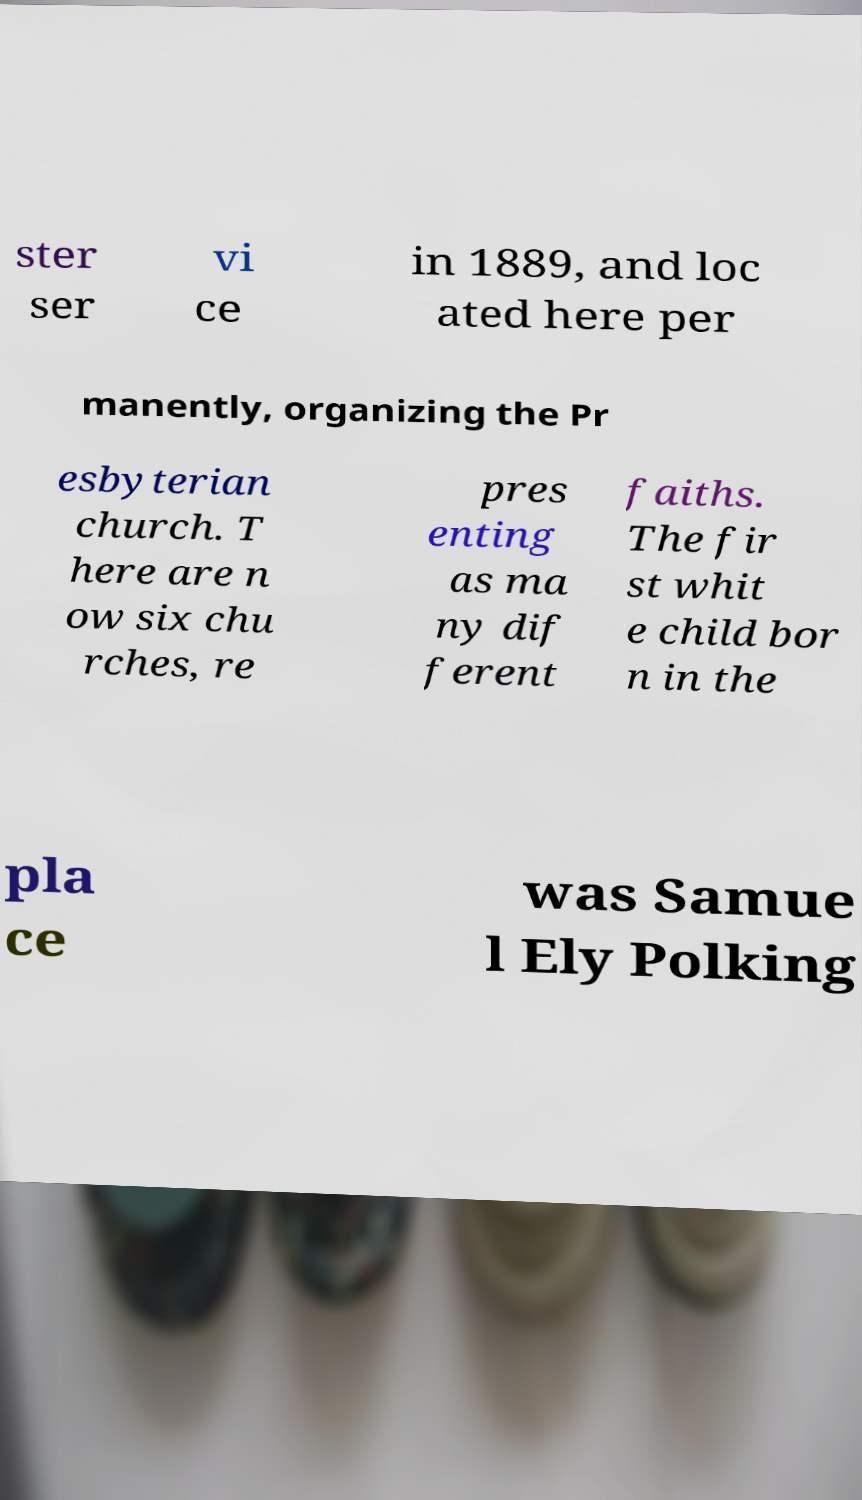Can you accurately transcribe the text from the provided image for me? ster ser vi ce in 1889, and loc ated here per manently, organizing the Pr esbyterian church. T here are n ow six chu rches, re pres enting as ma ny dif ferent faiths. The fir st whit e child bor n in the pla ce was Samue l Ely Polking 